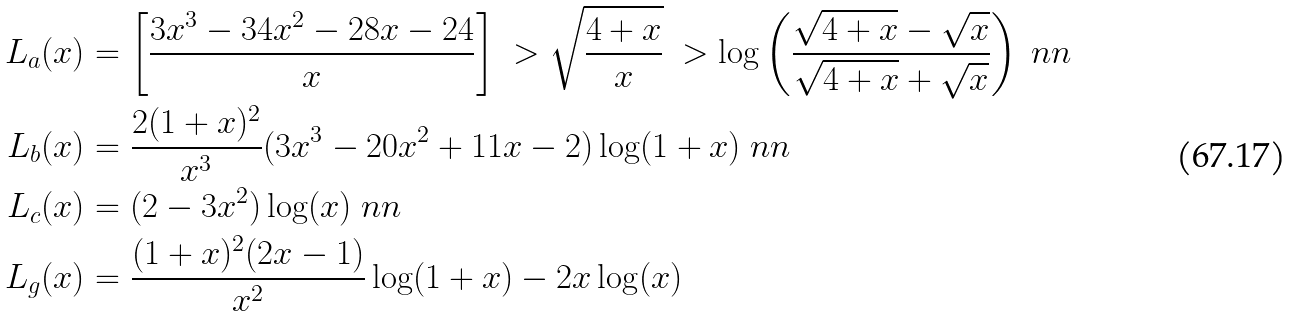Convert formula to latex. <formula><loc_0><loc_0><loc_500><loc_500>L _ { a } ( x ) & = \left [ \frac { 3 x ^ { 3 } - 3 4 x ^ { 2 } - 2 8 x - 2 4 } { x } \right ] \ > \sqrt { \frac { 4 + x } { x } } \ > \log \left ( \frac { \sqrt { 4 + x } - \sqrt { x } } { \sqrt { 4 + x } + \sqrt { x } } \right ) \ n n \\ L _ { b } ( x ) & = \frac { 2 ( 1 + x ) ^ { 2 } } { x ^ { 3 } } ( 3 x ^ { 3 } - 2 0 x ^ { 2 } + 1 1 x - 2 ) \log ( 1 + x ) \ n n \\ L _ { c } ( x ) & = ( 2 - 3 x ^ { 2 } ) \log ( x ) \ n n \\ L _ { g } ( x ) & = \frac { ( 1 + x ) ^ { 2 } ( 2 x - 1 ) } { x ^ { 2 } } \log ( 1 + x ) - 2 x \log ( x )</formula> 